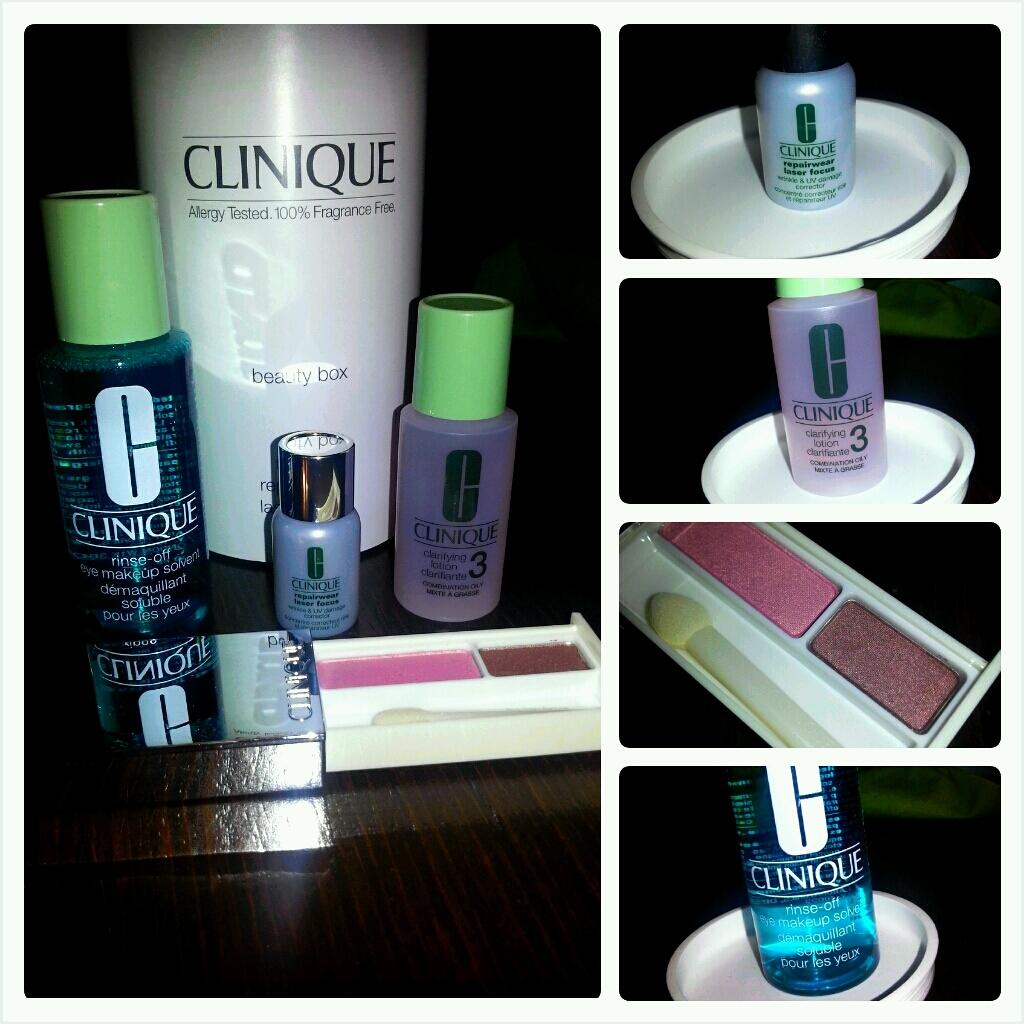<image>
Present a compact description of the photo's key features. Several bottles of Clinique makeup  next to each other on a wooden table. 